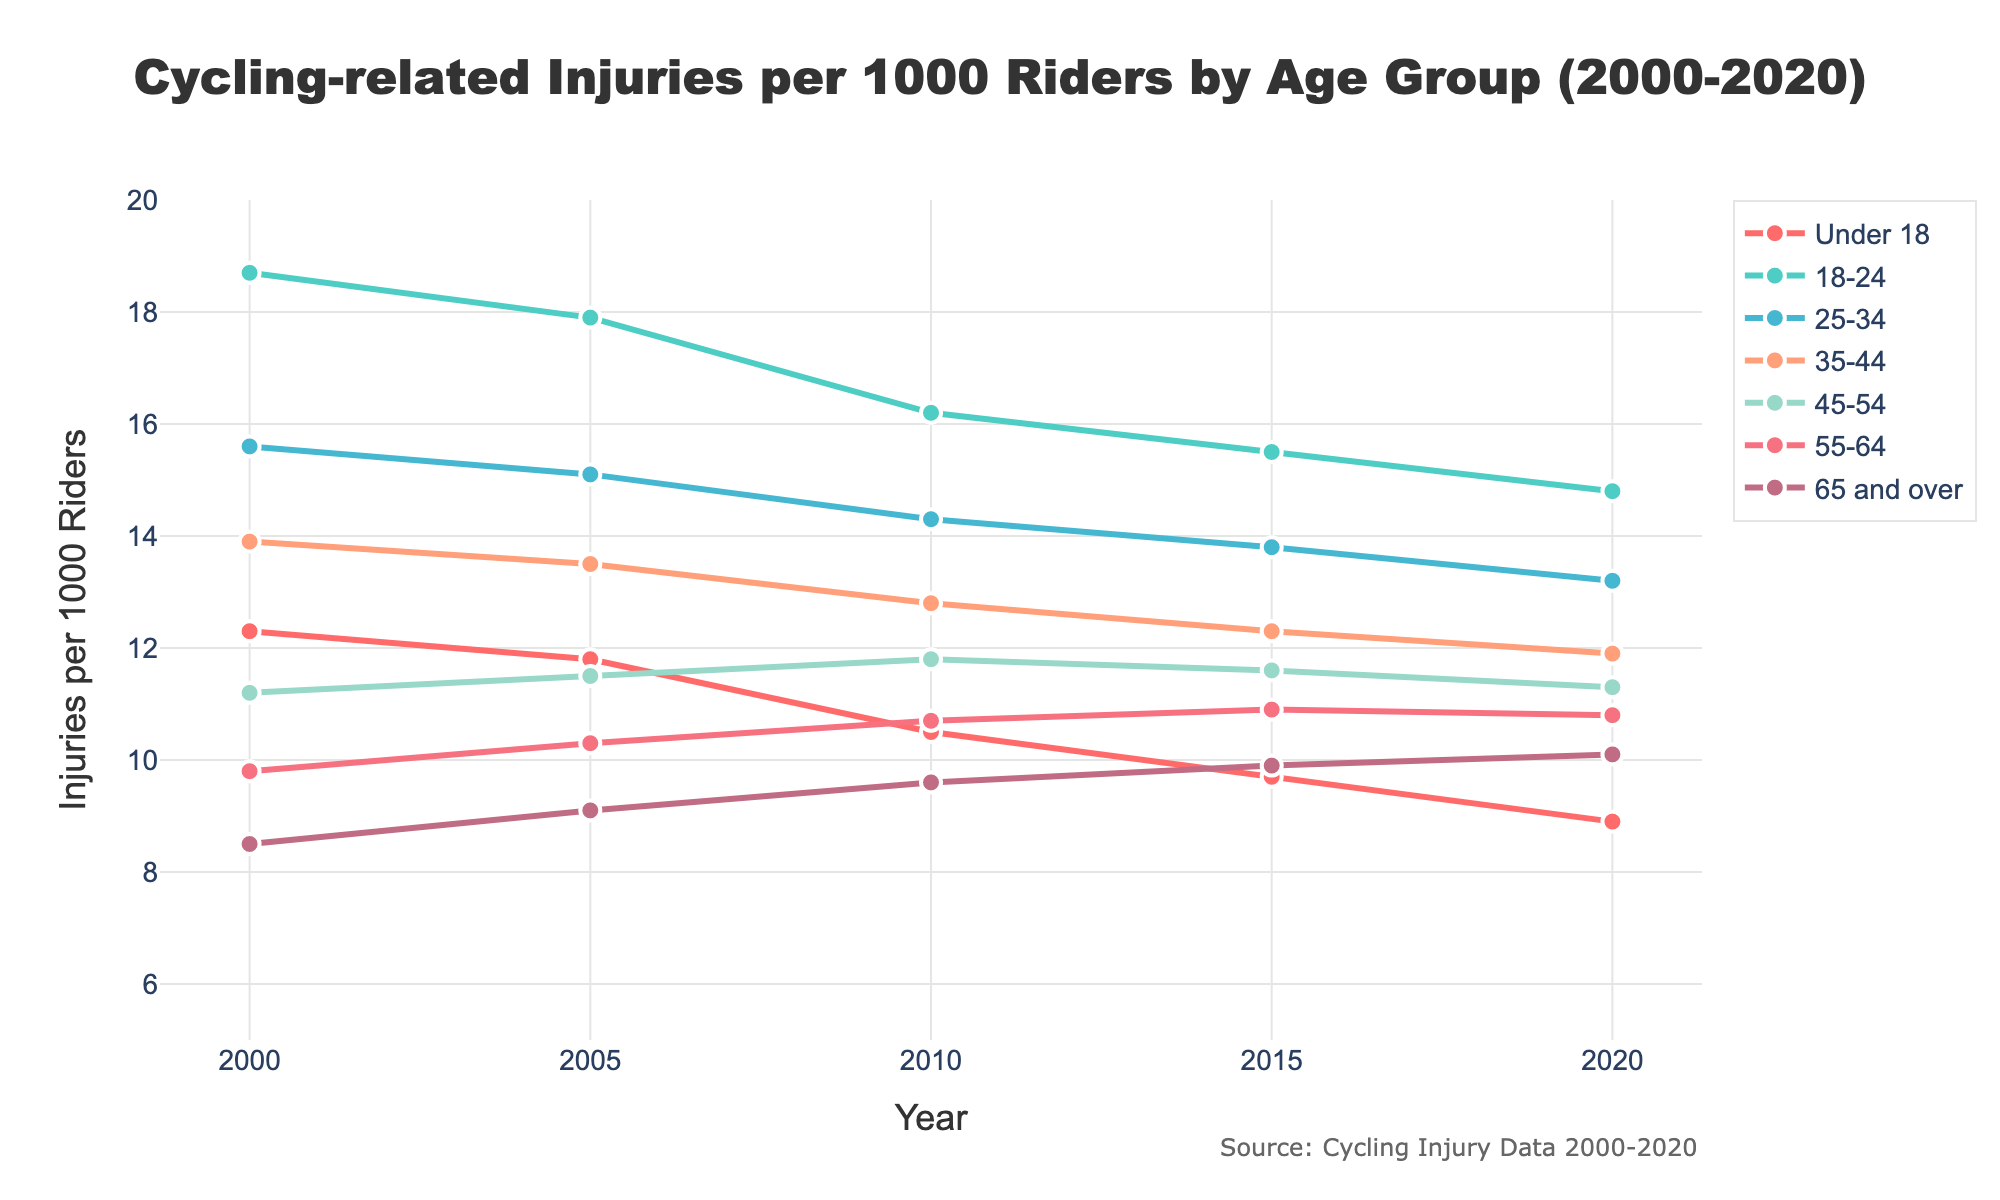What is the trend in cycling injuries for the age group 'Under 18' from 2000 to 2020? The injuries per 1000 riders for the 'Under 18' age group show a downward trend, starting at 12.3 in 2000 and decreasing to 8.9 in 2020.
Answer: Downward Which age group saw an increase in cycling injuries from 2000 to 2020? The '65 and over' age group saw an increase in cycling injuries, starting at 8.5 in 2000 and rising to 10.1 in 2020.
Answer: 65 and over What was the difference in cycling injuries per 1000 riders between the age groups '18-24' and '55-64' in 2000? In 2000, the '18-24' age group had 18.7 injuries per 1000 riders and the '55-64' age group had 9.8 injuries. The difference is 18.7 - 9.8 = 8.9.
Answer: 8.9 Which age group had the highest rate of cycling injuries in 2020? The '18-24' age group had the highest rate of cycling injuries in 2020, with 14.8 injuries per 1000 riders.
Answer: 18-24 How did the rate of cycling injuries for the age group '35-44' change from 2000 to 2020? The rate of cycling injuries for the '35-44' age group decreased over time, starting at 13.9 in 2000 and dropping to 11.9 in 2020.
Answer: Decreased Among all age groups, which one had the smallest change in injuries per 1000 riders between 2000 and 2020? The '45-54' age group had the smallest change, starting at 11.2 in 2000 and ending at 11.3 in 2020, a change of just 0.1.
Answer: 45-54 Compare the rate of decline in cycling injuries between the 'Under 18' and '25-34' age groups from 2000 to 2020. The 'Under 18' age group saw a decline from 12.3 to 8.9, a reduction of 3.4. The '25-34' age group saw a decline from 15.6 to 13.2, a reduction of 2.4. Therefore, the 'Under 18' group experienced a greater decline in injuries.
Answer: Under 18 What is the average rate of cycling injuries for the '55-64' age group across the years 2000, 2005, 2010, 2015, and 2020? The rates for the '55-64' age group are 9.8 (2000), 10.3 (2005), 10.7 (2010), 10.9 (2015), and 10.8 (2020). The average is (9.8 + 10.3 + 10.7 + 10.9 + 10.8) / 5 = 10.5.
Answer: 10.5 Identify the age group whose highest rate of cycling injuries in the 20-year span does not exceed 13 per 1000 riders. The '65 and over' age group has the highest rate of 10.1 per 1000 riders in the given data, which does not exceed 13.
Answer: 65 and over 